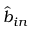<formula> <loc_0><loc_0><loc_500><loc_500>\hat { b } _ { i n }</formula> 